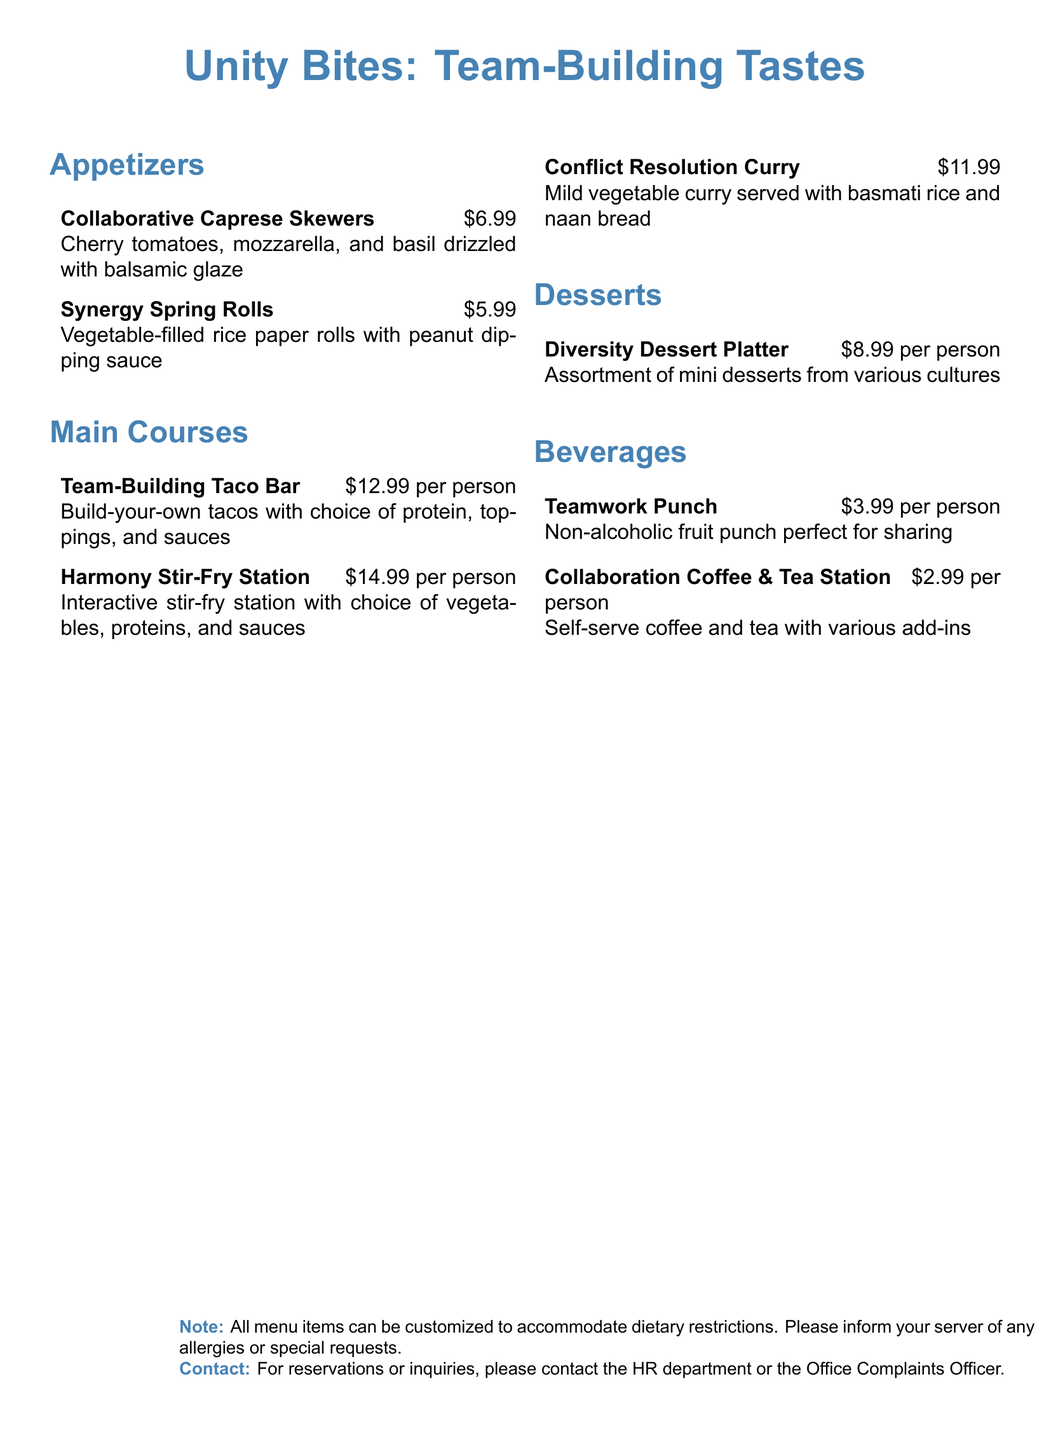what is the price of the Collaborative Caprese Skewers? The price is stated next to the menu item, which is $6.99.
Answer: $6.99 how much does the Team-Building Taco Bar cost per person? The cost per person for this main course is mentioned as $12.99.
Answer: $12.99 what is included in the Diversity Dessert Platter? The document describes this dessert as an assortment of mini desserts from various cultures.
Answer: Assortment of mini desserts from various cultures how much is the Teamwork Punch? The beverage's price is given in the menu as $3.99 per person.
Answer: $3.99 is the menu customizable for dietary restrictions? The note at the bottom of the document states that all menu items can be customized to accommodate dietary restrictions.
Answer: Yes what type of station is featured in the Harmony Stir-Fry Station? The menu describes it as an interactive stir-fry station.
Answer: Interactive stir-fry station how many appetizers are listed on the menu? There are a total of two appetizers mentioned in the menu.
Answer: 2 what is the main theme of the menu title? The title indicates a focus on team-building.
Answer: Team-Building Tastes 